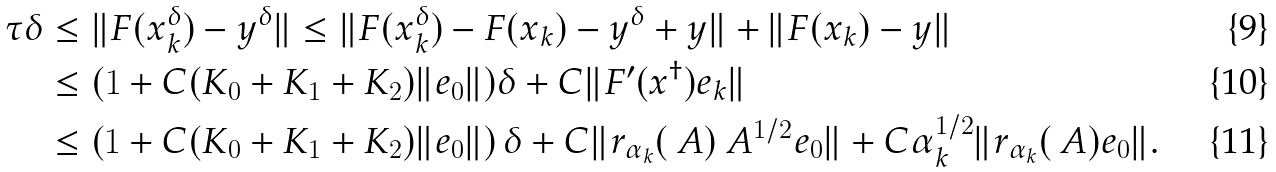<formula> <loc_0><loc_0><loc_500><loc_500>\tau \delta & \leq \| F ( x _ { k } ^ { \delta } ) - y ^ { \delta } \| \leq \| F ( x _ { k } ^ { \delta } ) - F ( x _ { k } ) - y ^ { \delta } + y \| + \| F ( x _ { k } ) - y \| \\ & \leq ( 1 + C ( K _ { 0 } + K _ { 1 } + K _ { 2 } ) \| e _ { 0 } \| ) \delta + C \| F ^ { \prime } ( x ^ { \dag } ) e _ { k } \| \\ & \leq \left ( 1 + C ( K _ { 0 } + K _ { 1 } + K _ { 2 } ) \| e _ { 0 } \| \right ) \delta + C \| r _ { \alpha _ { k } } ( \ A ) \ A ^ { 1 / 2 } e _ { 0 } \| + C \alpha _ { k } ^ { 1 / 2 } \| r _ { \alpha _ { k } } ( \ A ) e _ { 0 } \| .</formula> 